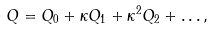<formula> <loc_0><loc_0><loc_500><loc_500>Q = Q _ { 0 } + \kappa Q _ { 1 } + \kappa ^ { 2 } Q _ { 2 } + \dots ,</formula> 